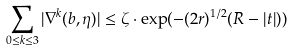<formula> <loc_0><loc_0><loc_500><loc_500>\sum _ { 0 \leq k \leq 3 } | \nabla ^ { k } ( b , \eta ) | \leq \zeta \cdot \exp ( - ( 2 r ) ^ { 1 / 2 } ( R - | t | ) )</formula> 